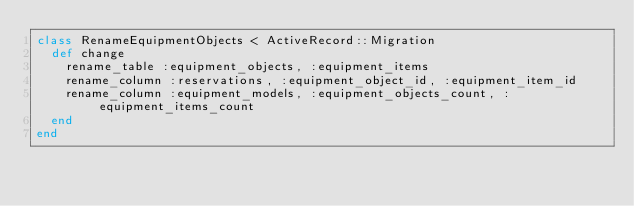<code> <loc_0><loc_0><loc_500><loc_500><_Ruby_>class RenameEquipmentObjects < ActiveRecord::Migration
  def change
  	rename_table :equipment_objects, :equipment_items
  	rename_column :reservations, :equipment_object_id, :equipment_item_id
  	rename_column :equipment_models, :equipment_objects_count, :equipment_items_count
  end
end
</code> 